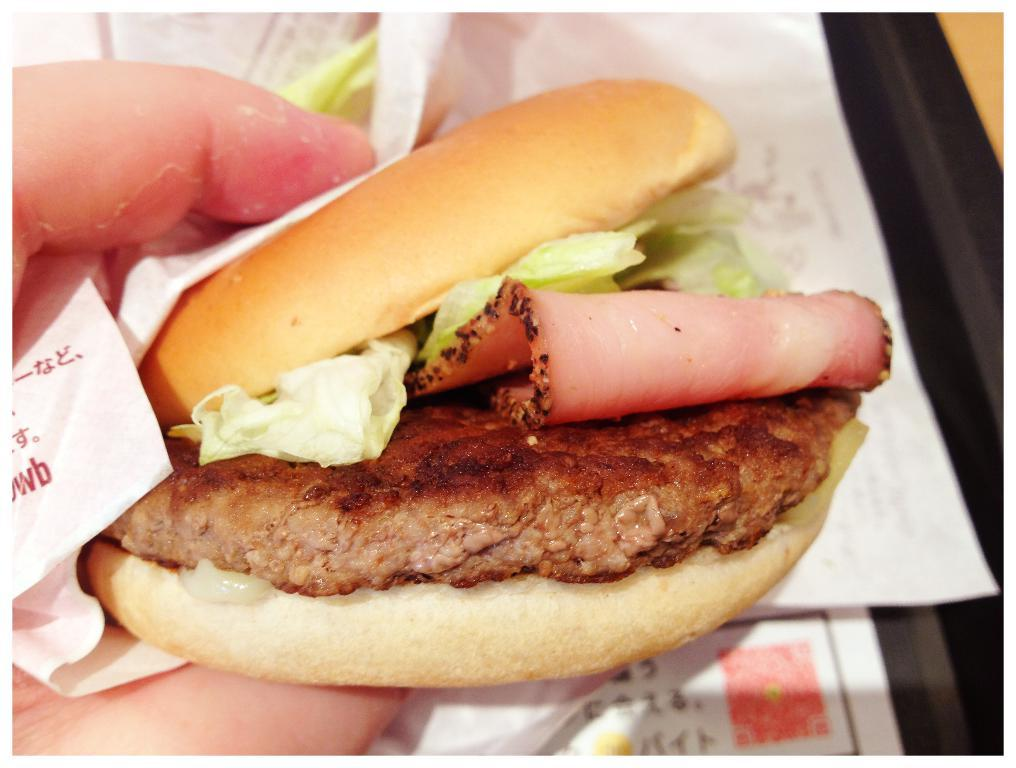Who or what is the main subject in the image? There is a person in the image. What is the person holding in the image? The person is holding a burger. Can you describe the background of the image? The background of the image is blurred. What rule does the person's mind follow in the image? There is no information about the person's mind or any rules in the image. 